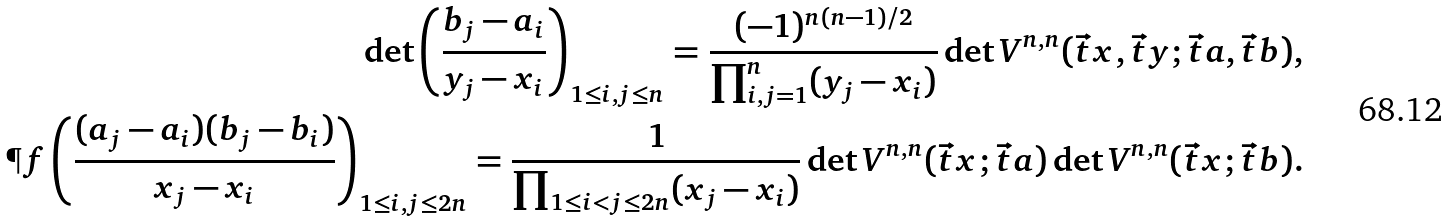<formula> <loc_0><loc_0><loc_500><loc_500>\det \left ( \frac { b _ { j } - a _ { i } } { y _ { j } - x _ { i } } \right ) _ { 1 \leq i , j \leq n } = \frac { ( - 1 ) ^ { n ( n - 1 ) / 2 } } { \prod _ { i , j = 1 } ^ { n } ( y _ { j } - x _ { i } ) } \det V ^ { n , n } ( \vec { t } x , \vec { t } y ; \vec { t } a , \vec { t } b ) , \\ \P f \left ( \frac { ( a _ { j } - a _ { i } ) ( b _ { j } - b _ { i } ) } { x _ { j } - x _ { i } } \right ) _ { 1 \leq i , j \leq 2 n } = \frac { 1 } { \prod _ { 1 \leq i < j \leq 2 n } ( x _ { j } - x _ { i } ) } \det V ^ { n , n } ( \vec { t } x ; \vec { t } a ) \det V ^ { n , n } ( \vec { t } x ; \vec { t } b ) .</formula> 